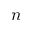<formula> <loc_0><loc_0><loc_500><loc_500>n</formula> 